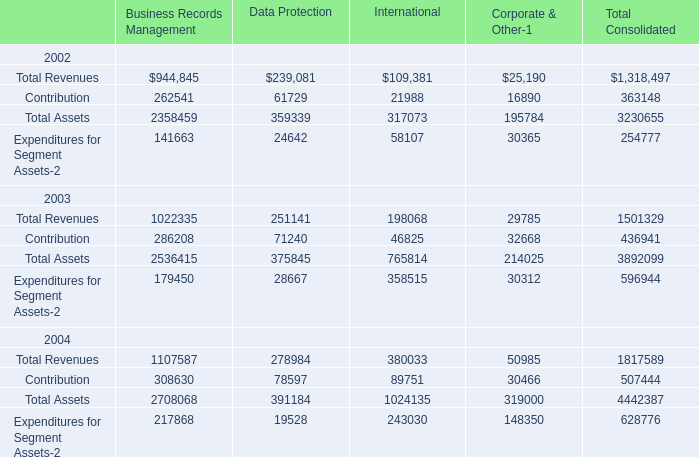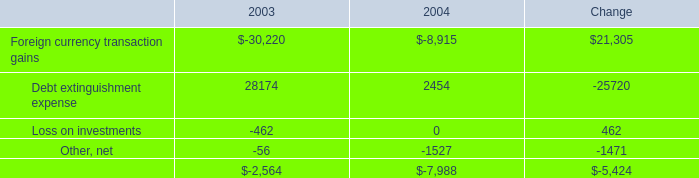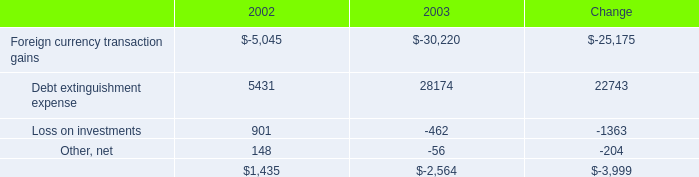What is the growing rate of Debt extinguishment expense in the year with the most Business Records Management for Total Assets ? 
Computations: ((2454 - 28174) / 28174)
Answer: -0.9129. 